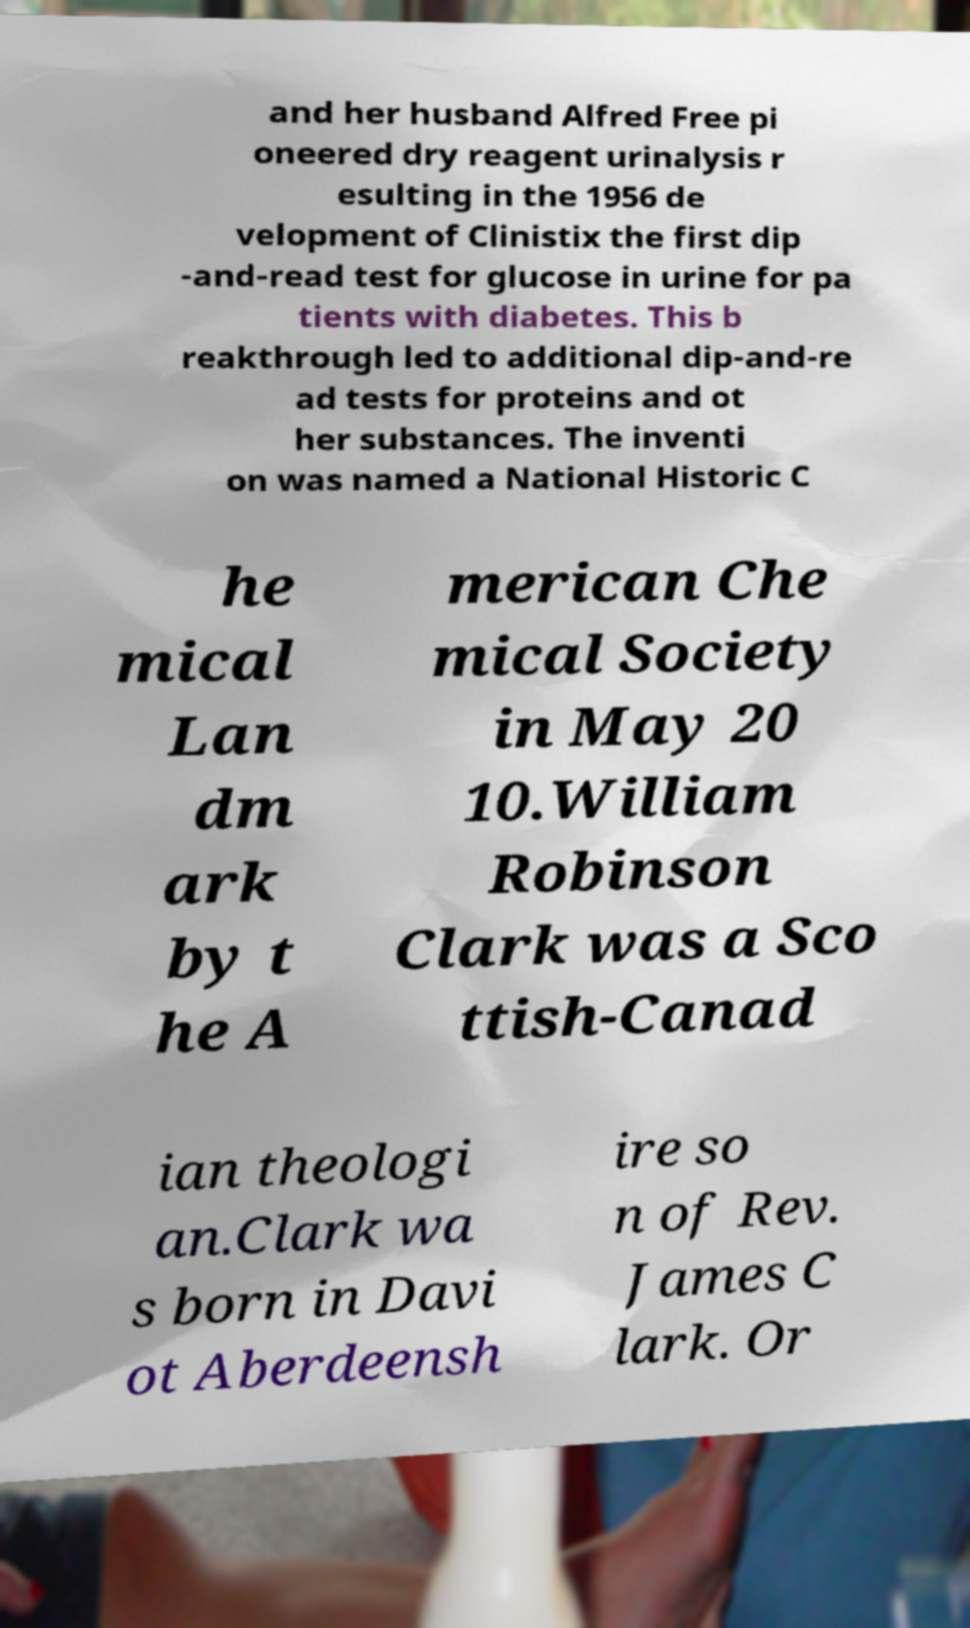Can you accurately transcribe the text from the provided image for me? and her husband Alfred Free pi oneered dry reagent urinalysis r esulting in the 1956 de velopment of Clinistix the first dip -and-read test for glucose in urine for pa tients with diabetes. This b reakthrough led to additional dip-and-re ad tests for proteins and ot her substances. The inventi on was named a National Historic C he mical Lan dm ark by t he A merican Che mical Society in May 20 10.William Robinson Clark was a Sco ttish-Canad ian theologi an.Clark wa s born in Davi ot Aberdeensh ire so n of Rev. James C lark. Or 